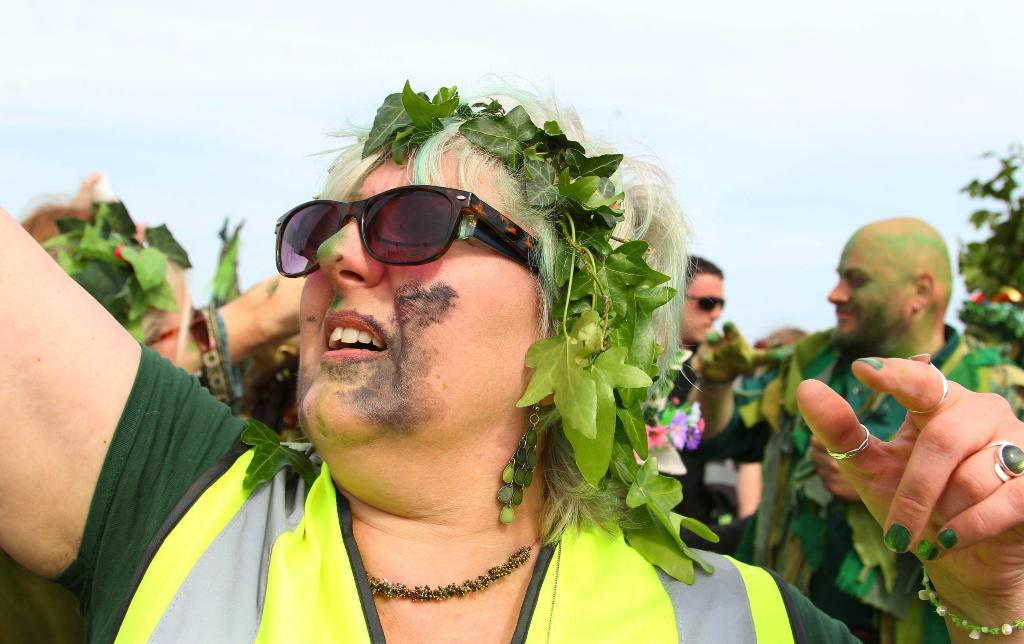What are the people in the image wearing? The people in the image are wearing costumes. What can be seen in the background of the image? There is a sky visible in the background of the image. How much dirt is present on the arm of the person in the image? There is no dirt present on the arm of the person in the image, as the focus is on the costumes they are wearing. 